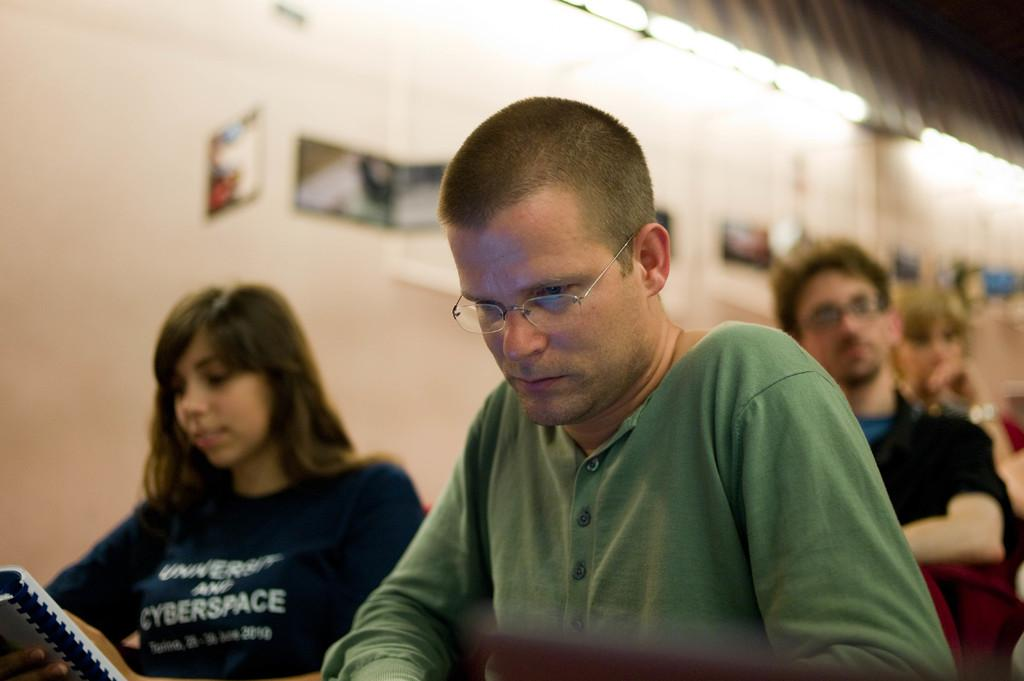How many people are present in the image? There are three people in the image. What is the person in front wearing? The person in front is wearing a green color shirt. What is the woman holding in the image? The woman is holding a book. What can be seen in the background of the image? There is a building in the background of the image. What is the color of the building? The building is white in color. How many chickens are present in the image? There are no chickens present in the image. What type of bit is the girl using to eat the apple in the image? There is no girl or apple present in the image. 